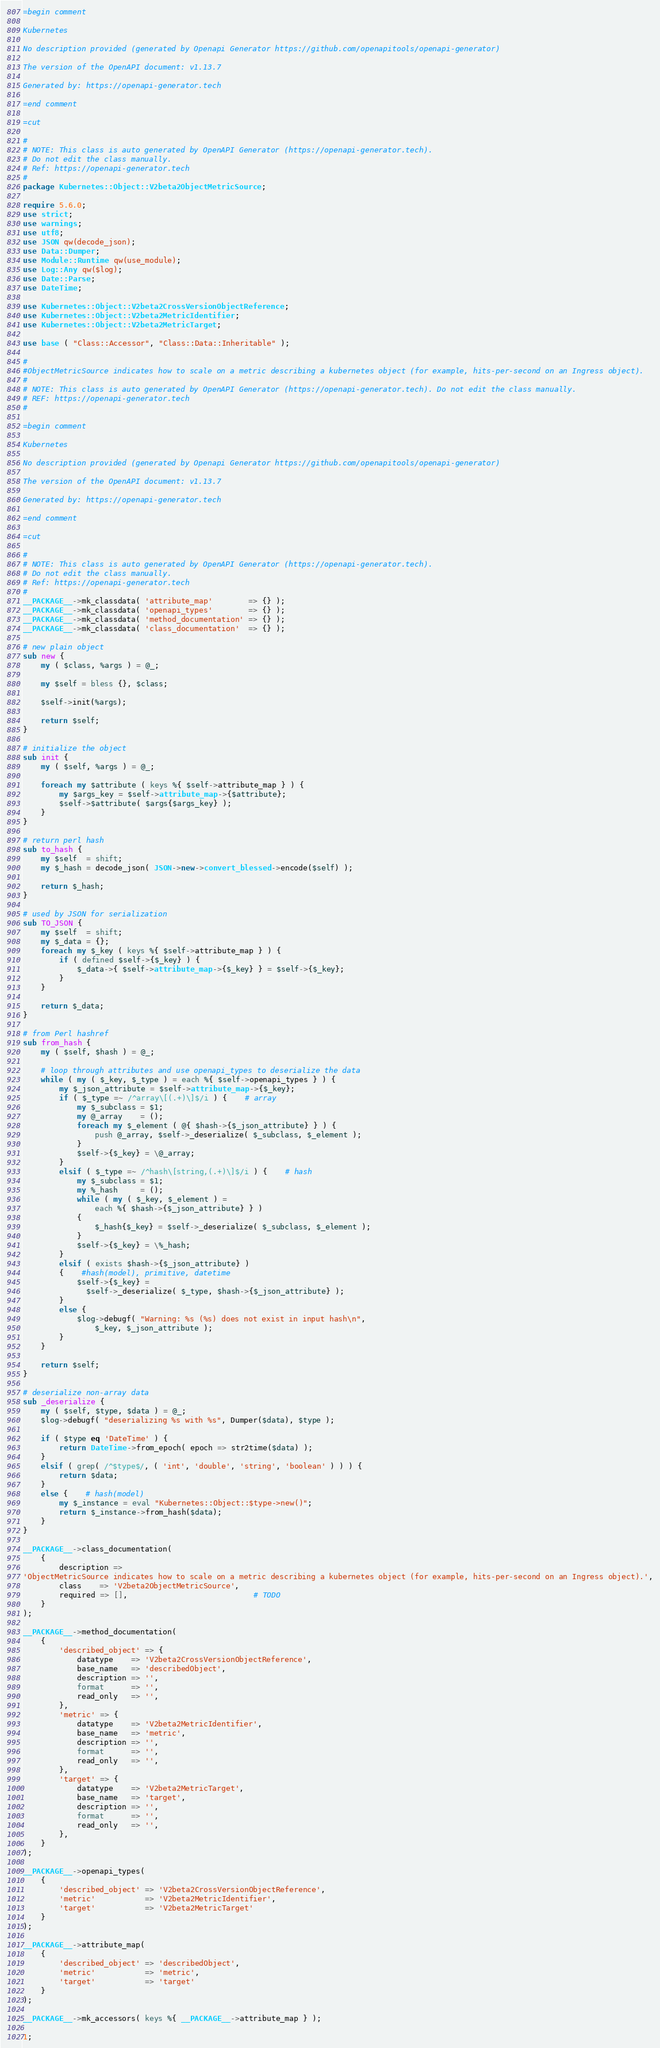<code> <loc_0><loc_0><loc_500><loc_500><_Perl_>
=begin comment

Kubernetes

No description provided (generated by Openapi Generator https://github.com/openapitools/openapi-generator)

The version of the OpenAPI document: v1.13.7

Generated by: https://openapi-generator.tech

=end comment

=cut

#
# NOTE: This class is auto generated by OpenAPI Generator (https://openapi-generator.tech).
# Do not edit the class manually.
# Ref: https://openapi-generator.tech
#
package Kubernetes::Object::V2beta2ObjectMetricSource;

require 5.6.0;
use strict;
use warnings;
use utf8;
use JSON qw(decode_json);
use Data::Dumper;
use Module::Runtime qw(use_module);
use Log::Any qw($log);
use Date::Parse;
use DateTime;

use Kubernetes::Object::V2beta2CrossVersionObjectReference;
use Kubernetes::Object::V2beta2MetricIdentifier;
use Kubernetes::Object::V2beta2MetricTarget;

use base ( "Class::Accessor", "Class::Data::Inheritable" );

#
#ObjectMetricSource indicates how to scale on a metric describing a kubernetes object (for example, hits-per-second on an Ingress object).
#
# NOTE: This class is auto generated by OpenAPI Generator (https://openapi-generator.tech). Do not edit the class manually.
# REF: https://openapi-generator.tech
#

=begin comment

Kubernetes

No description provided (generated by Openapi Generator https://github.com/openapitools/openapi-generator)

The version of the OpenAPI document: v1.13.7

Generated by: https://openapi-generator.tech

=end comment

=cut

#
# NOTE: This class is auto generated by OpenAPI Generator (https://openapi-generator.tech).
# Do not edit the class manually.
# Ref: https://openapi-generator.tech
#
__PACKAGE__->mk_classdata( 'attribute_map'        => {} );
__PACKAGE__->mk_classdata( 'openapi_types'        => {} );
__PACKAGE__->mk_classdata( 'method_documentation' => {} );
__PACKAGE__->mk_classdata( 'class_documentation'  => {} );

# new plain object
sub new {
    my ( $class, %args ) = @_;

    my $self = bless {}, $class;

    $self->init(%args);

    return $self;
}

# initialize the object
sub init {
    my ( $self, %args ) = @_;

    foreach my $attribute ( keys %{ $self->attribute_map } ) {
        my $args_key = $self->attribute_map->{$attribute};
        $self->$attribute( $args{$args_key} );
    }
}

# return perl hash
sub to_hash {
    my $self  = shift;
    my $_hash = decode_json( JSON->new->convert_blessed->encode($self) );

    return $_hash;
}

# used by JSON for serialization
sub TO_JSON {
    my $self  = shift;
    my $_data = {};
    foreach my $_key ( keys %{ $self->attribute_map } ) {
        if ( defined $self->{$_key} ) {
            $_data->{ $self->attribute_map->{$_key} } = $self->{$_key};
        }
    }

    return $_data;
}

# from Perl hashref
sub from_hash {
    my ( $self, $hash ) = @_;

    # loop through attributes and use openapi_types to deserialize the data
    while ( my ( $_key, $_type ) = each %{ $self->openapi_types } ) {
        my $_json_attribute = $self->attribute_map->{$_key};
        if ( $_type =~ /^array\[(.+)\]$/i ) {    # array
            my $_subclass = $1;
            my @_array    = ();
            foreach my $_element ( @{ $hash->{$_json_attribute} } ) {
                push @_array, $self->_deserialize( $_subclass, $_element );
            }
            $self->{$_key} = \@_array;
        }
        elsif ( $_type =~ /^hash\[string,(.+)\]$/i ) {    # hash
            my $_subclass = $1;
            my %_hash     = ();
            while ( my ( $_key, $_element ) =
                each %{ $hash->{$_json_attribute} } )
            {
                $_hash{$_key} = $self->_deserialize( $_subclass, $_element );
            }
            $self->{$_key} = \%_hash;
        }
        elsif ( exists $hash->{$_json_attribute} )
        {    #hash(model), primitive, datetime
            $self->{$_key} =
              $self->_deserialize( $_type, $hash->{$_json_attribute} );
        }
        else {
            $log->debugf( "Warning: %s (%s) does not exist in input hash\n",
                $_key, $_json_attribute );
        }
    }

    return $self;
}

# deserialize non-array data
sub _deserialize {
    my ( $self, $type, $data ) = @_;
    $log->debugf( "deserializing %s with %s", Dumper($data), $type );

    if ( $type eq 'DateTime' ) {
        return DateTime->from_epoch( epoch => str2time($data) );
    }
    elsif ( grep( /^$type$/, ( 'int', 'double', 'string', 'boolean' ) ) ) {
        return $data;
    }
    else {    # hash(model)
        my $_instance = eval "Kubernetes::Object::$type->new()";
        return $_instance->from_hash($data);
    }
}

__PACKAGE__->class_documentation(
    {
        description =>
'ObjectMetricSource indicates how to scale on a metric describing a kubernetes object (for example, hits-per-second on an Ingress object).',
        class    => 'V2beta2ObjectMetricSource',
        required => [],                            # TODO
    }
);

__PACKAGE__->method_documentation(
    {
        'described_object' => {
            datatype    => 'V2beta2CrossVersionObjectReference',
            base_name   => 'describedObject',
            description => '',
            format      => '',
            read_only   => '',
        },
        'metric' => {
            datatype    => 'V2beta2MetricIdentifier',
            base_name   => 'metric',
            description => '',
            format      => '',
            read_only   => '',
        },
        'target' => {
            datatype    => 'V2beta2MetricTarget',
            base_name   => 'target',
            description => '',
            format      => '',
            read_only   => '',
        },
    }
);

__PACKAGE__->openapi_types(
    {
        'described_object' => 'V2beta2CrossVersionObjectReference',
        'metric'           => 'V2beta2MetricIdentifier',
        'target'           => 'V2beta2MetricTarget'
    }
);

__PACKAGE__->attribute_map(
    {
        'described_object' => 'describedObject',
        'metric'           => 'metric',
        'target'           => 'target'
    }
);

__PACKAGE__->mk_accessors( keys %{ __PACKAGE__->attribute_map } );

1;
</code> 